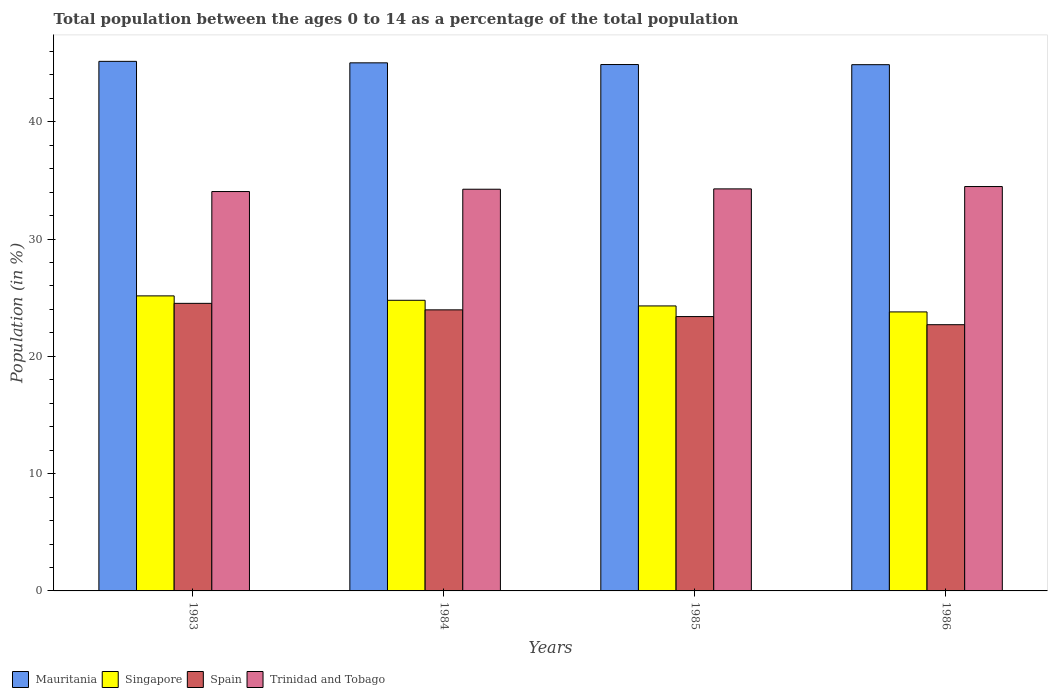How many groups of bars are there?
Your answer should be very brief. 4. Are the number of bars per tick equal to the number of legend labels?
Offer a very short reply. Yes. How many bars are there on the 1st tick from the right?
Your answer should be very brief. 4. What is the label of the 3rd group of bars from the left?
Offer a very short reply. 1985. In how many cases, is the number of bars for a given year not equal to the number of legend labels?
Offer a very short reply. 0. What is the percentage of the population ages 0 to 14 in Trinidad and Tobago in 1985?
Your answer should be very brief. 34.28. Across all years, what is the maximum percentage of the population ages 0 to 14 in Mauritania?
Provide a short and direct response. 45.15. Across all years, what is the minimum percentage of the population ages 0 to 14 in Mauritania?
Provide a short and direct response. 44.87. In which year was the percentage of the population ages 0 to 14 in Trinidad and Tobago maximum?
Give a very brief answer. 1986. What is the total percentage of the population ages 0 to 14 in Spain in the graph?
Provide a short and direct response. 94.57. What is the difference between the percentage of the population ages 0 to 14 in Spain in 1983 and that in 1984?
Ensure brevity in your answer.  0.55. What is the difference between the percentage of the population ages 0 to 14 in Singapore in 1986 and the percentage of the population ages 0 to 14 in Mauritania in 1983?
Offer a very short reply. -21.36. What is the average percentage of the population ages 0 to 14 in Singapore per year?
Your answer should be compact. 24.5. In the year 1983, what is the difference between the percentage of the population ages 0 to 14 in Spain and percentage of the population ages 0 to 14 in Mauritania?
Your answer should be very brief. -20.63. What is the ratio of the percentage of the population ages 0 to 14 in Mauritania in 1985 to that in 1986?
Offer a terse response. 1. What is the difference between the highest and the second highest percentage of the population ages 0 to 14 in Singapore?
Offer a very short reply. 0.38. What is the difference between the highest and the lowest percentage of the population ages 0 to 14 in Spain?
Your answer should be very brief. 1.82. Is it the case that in every year, the sum of the percentage of the population ages 0 to 14 in Singapore and percentage of the population ages 0 to 14 in Mauritania is greater than the sum of percentage of the population ages 0 to 14 in Trinidad and Tobago and percentage of the population ages 0 to 14 in Spain?
Your answer should be compact. No. What does the 2nd bar from the left in 1984 represents?
Ensure brevity in your answer.  Singapore. What does the 3rd bar from the right in 1985 represents?
Provide a succinct answer. Singapore. Is it the case that in every year, the sum of the percentage of the population ages 0 to 14 in Singapore and percentage of the population ages 0 to 14 in Spain is greater than the percentage of the population ages 0 to 14 in Trinidad and Tobago?
Your answer should be compact. Yes. How many bars are there?
Your answer should be compact. 16. What is the difference between two consecutive major ticks on the Y-axis?
Keep it short and to the point. 10. How many legend labels are there?
Give a very brief answer. 4. How are the legend labels stacked?
Provide a succinct answer. Horizontal. What is the title of the graph?
Provide a short and direct response. Total population between the ages 0 to 14 as a percentage of the total population. Does "Hungary" appear as one of the legend labels in the graph?
Offer a terse response. No. What is the label or title of the X-axis?
Provide a short and direct response. Years. What is the Population (in %) of Mauritania in 1983?
Offer a very short reply. 45.15. What is the Population (in %) in Singapore in 1983?
Offer a terse response. 25.15. What is the Population (in %) of Spain in 1983?
Your answer should be very brief. 24.52. What is the Population (in %) in Trinidad and Tobago in 1983?
Give a very brief answer. 34.05. What is the Population (in %) in Mauritania in 1984?
Make the answer very short. 45.02. What is the Population (in %) in Singapore in 1984?
Give a very brief answer. 24.78. What is the Population (in %) of Spain in 1984?
Provide a succinct answer. 23.96. What is the Population (in %) in Trinidad and Tobago in 1984?
Make the answer very short. 34.25. What is the Population (in %) of Mauritania in 1985?
Your answer should be very brief. 44.88. What is the Population (in %) of Singapore in 1985?
Provide a succinct answer. 24.3. What is the Population (in %) in Spain in 1985?
Keep it short and to the point. 23.39. What is the Population (in %) in Trinidad and Tobago in 1985?
Give a very brief answer. 34.28. What is the Population (in %) of Mauritania in 1986?
Provide a short and direct response. 44.87. What is the Population (in %) in Singapore in 1986?
Make the answer very short. 23.79. What is the Population (in %) of Spain in 1986?
Offer a terse response. 22.7. What is the Population (in %) of Trinidad and Tobago in 1986?
Provide a succinct answer. 34.48. Across all years, what is the maximum Population (in %) in Mauritania?
Keep it short and to the point. 45.15. Across all years, what is the maximum Population (in %) of Singapore?
Give a very brief answer. 25.15. Across all years, what is the maximum Population (in %) of Spain?
Your response must be concise. 24.52. Across all years, what is the maximum Population (in %) in Trinidad and Tobago?
Provide a succinct answer. 34.48. Across all years, what is the minimum Population (in %) of Mauritania?
Your answer should be compact. 44.87. Across all years, what is the minimum Population (in %) in Singapore?
Your answer should be very brief. 23.79. Across all years, what is the minimum Population (in %) in Spain?
Offer a terse response. 22.7. Across all years, what is the minimum Population (in %) in Trinidad and Tobago?
Your response must be concise. 34.05. What is the total Population (in %) of Mauritania in the graph?
Your answer should be very brief. 179.91. What is the total Population (in %) in Singapore in the graph?
Provide a short and direct response. 98.02. What is the total Population (in %) in Spain in the graph?
Ensure brevity in your answer.  94.57. What is the total Population (in %) in Trinidad and Tobago in the graph?
Make the answer very short. 137.05. What is the difference between the Population (in %) of Mauritania in 1983 and that in 1984?
Offer a terse response. 0.13. What is the difference between the Population (in %) in Singapore in 1983 and that in 1984?
Your answer should be compact. 0.38. What is the difference between the Population (in %) in Spain in 1983 and that in 1984?
Provide a short and direct response. 0.55. What is the difference between the Population (in %) in Trinidad and Tobago in 1983 and that in 1984?
Keep it short and to the point. -0.2. What is the difference between the Population (in %) in Mauritania in 1983 and that in 1985?
Give a very brief answer. 0.27. What is the difference between the Population (in %) in Singapore in 1983 and that in 1985?
Make the answer very short. 0.86. What is the difference between the Population (in %) of Spain in 1983 and that in 1985?
Offer a very short reply. 1.13. What is the difference between the Population (in %) of Trinidad and Tobago in 1983 and that in 1985?
Offer a terse response. -0.23. What is the difference between the Population (in %) in Mauritania in 1983 and that in 1986?
Give a very brief answer. 0.28. What is the difference between the Population (in %) of Singapore in 1983 and that in 1986?
Provide a succinct answer. 1.37. What is the difference between the Population (in %) of Spain in 1983 and that in 1986?
Offer a terse response. 1.82. What is the difference between the Population (in %) of Trinidad and Tobago in 1983 and that in 1986?
Make the answer very short. -0.43. What is the difference between the Population (in %) in Mauritania in 1984 and that in 1985?
Your answer should be compact. 0.14. What is the difference between the Population (in %) of Singapore in 1984 and that in 1985?
Your answer should be very brief. 0.48. What is the difference between the Population (in %) of Spain in 1984 and that in 1985?
Give a very brief answer. 0.57. What is the difference between the Population (in %) in Trinidad and Tobago in 1984 and that in 1985?
Provide a short and direct response. -0.03. What is the difference between the Population (in %) of Mauritania in 1984 and that in 1986?
Provide a succinct answer. 0.16. What is the difference between the Population (in %) of Spain in 1984 and that in 1986?
Your answer should be compact. 1.26. What is the difference between the Population (in %) of Trinidad and Tobago in 1984 and that in 1986?
Make the answer very short. -0.23. What is the difference between the Population (in %) of Mauritania in 1985 and that in 1986?
Give a very brief answer. 0.01. What is the difference between the Population (in %) of Singapore in 1985 and that in 1986?
Your answer should be very brief. 0.51. What is the difference between the Population (in %) of Spain in 1985 and that in 1986?
Make the answer very short. 0.69. What is the difference between the Population (in %) in Trinidad and Tobago in 1985 and that in 1986?
Ensure brevity in your answer.  -0.2. What is the difference between the Population (in %) of Mauritania in 1983 and the Population (in %) of Singapore in 1984?
Keep it short and to the point. 20.37. What is the difference between the Population (in %) in Mauritania in 1983 and the Population (in %) in Spain in 1984?
Your answer should be compact. 21.19. What is the difference between the Population (in %) of Mauritania in 1983 and the Population (in %) of Trinidad and Tobago in 1984?
Your response must be concise. 10.9. What is the difference between the Population (in %) of Singapore in 1983 and the Population (in %) of Spain in 1984?
Offer a terse response. 1.19. What is the difference between the Population (in %) in Singapore in 1983 and the Population (in %) in Trinidad and Tobago in 1984?
Your response must be concise. -9.09. What is the difference between the Population (in %) of Spain in 1983 and the Population (in %) of Trinidad and Tobago in 1984?
Your response must be concise. -9.73. What is the difference between the Population (in %) in Mauritania in 1983 and the Population (in %) in Singapore in 1985?
Make the answer very short. 20.85. What is the difference between the Population (in %) of Mauritania in 1983 and the Population (in %) of Spain in 1985?
Keep it short and to the point. 21.76. What is the difference between the Population (in %) in Mauritania in 1983 and the Population (in %) in Trinidad and Tobago in 1985?
Your response must be concise. 10.87. What is the difference between the Population (in %) of Singapore in 1983 and the Population (in %) of Spain in 1985?
Ensure brevity in your answer.  1.76. What is the difference between the Population (in %) in Singapore in 1983 and the Population (in %) in Trinidad and Tobago in 1985?
Ensure brevity in your answer.  -9.12. What is the difference between the Population (in %) of Spain in 1983 and the Population (in %) of Trinidad and Tobago in 1985?
Give a very brief answer. -9.76. What is the difference between the Population (in %) of Mauritania in 1983 and the Population (in %) of Singapore in 1986?
Offer a terse response. 21.36. What is the difference between the Population (in %) in Mauritania in 1983 and the Population (in %) in Spain in 1986?
Offer a very short reply. 22.45. What is the difference between the Population (in %) of Mauritania in 1983 and the Population (in %) of Trinidad and Tobago in 1986?
Provide a succinct answer. 10.67. What is the difference between the Population (in %) in Singapore in 1983 and the Population (in %) in Spain in 1986?
Your response must be concise. 2.46. What is the difference between the Population (in %) in Singapore in 1983 and the Population (in %) in Trinidad and Tobago in 1986?
Your answer should be compact. -9.32. What is the difference between the Population (in %) in Spain in 1983 and the Population (in %) in Trinidad and Tobago in 1986?
Give a very brief answer. -9.96. What is the difference between the Population (in %) of Mauritania in 1984 and the Population (in %) of Singapore in 1985?
Your response must be concise. 20.73. What is the difference between the Population (in %) in Mauritania in 1984 and the Population (in %) in Spain in 1985?
Your response must be concise. 21.63. What is the difference between the Population (in %) of Mauritania in 1984 and the Population (in %) of Trinidad and Tobago in 1985?
Offer a very short reply. 10.75. What is the difference between the Population (in %) in Singapore in 1984 and the Population (in %) in Spain in 1985?
Offer a terse response. 1.39. What is the difference between the Population (in %) of Singapore in 1984 and the Population (in %) of Trinidad and Tobago in 1985?
Provide a short and direct response. -9.5. What is the difference between the Population (in %) in Spain in 1984 and the Population (in %) in Trinidad and Tobago in 1985?
Ensure brevity in your answer.  -10.31. What is the difference between the Population (in %) in Mauritania in 1984 and the Population (in %) in Singapore in 1986?
Your answer should be very brief. 21.24. What is the difference between the Population (in %) of Mauritania in 1984 and the Population (in %) of Spain in 1986?
Your response must be concise. 22.32. What is the difference between the Population (in %) of Mauritania in 1984 and the Population (in %) of Trinidad and Tobago in 1986?
Give a very brief answer. 10.55. What is the difference between the Population (in %) of Singapore in 1984 and the Population (in %) of Spain in 1986?
Ensure brevity in your answer.  2.08. What is the difference between the Population (in %) of Singapore in 1984 and the Population (in %) of Trinidad and Tobago in 1986?
Make the answer very short. -9.7. What is the difference between the Population (in %) of Spain in 1984 and the Population (in %) of Trinidad and Tobago in 1986?
Offer a terse response. -10.51. What is the difference between the Population (in %) in Mauritania in 1985 and the Population (in %) in Singapore in 1986?
Give a very brief answer. 21.09. What is the difference between the Population (in %) of Mauritania in 1985 and the Population (in %) of Spain in 1986?
Your answer should be compact. 22.18. What is the difference between the Population (in %) in Mauritania in 1985 and the Population (in %) in Trinidad and Tobago in 1986?
Give a very brief answer. 10.4. What is the difference between the Population (in %) in Singapore in 1985 and the Population (in %) in Spain in 1986?
Provide a short and direct response. 1.6. What is the difference between the Population (in %) of Singapore in 1985 and the Population (in %) of Trinidad and Tobago in 1986?
Make the answer very short. -10.18. What is the difference between the Population (in %) in Spain in 1985 and the Population (in %) in Trinidad and Tobago in 1986?
Your response must be concise. -11.08. What is the average Population (in %) in Mauritania per year?
Your answer should be very brief. 44.98. What is the average Population (in %) of Singapore per year?
Make the answer very short. 24.5. What is the average Population (in %) of Spain per year?
Give a very brief answer. 23.64. What is the average Population (in %) in Trinidad and Tobago per year?
Provide a short and direct response. 34.26. In the year 1983, what is the difference between the Population (in %) in Mauritania and Population (in %) in Singapore?
Offer a very short reply. 19.99. In the year 1983, what is the difference between the Population (in %) in Mauritania and Population (in %) in Spain?
Your answer should be very brief. 20.63. In the year 1983, what is the difference between the Population (in %) in Mauritania and Population (in %) in Trinidad and Tobago?
Keep it short and to the point. 11.1. In the year 1983, what is the difference between the Population (in %) in Singapore and Population (in %) in Spain?
Provide a short and direct response. 0.64. In the year 1983, what is the difference between the Population (in %) of Singapore and Population (in %) of Trinidad and Tobago?
Provide a succinct answer. -8.9. In the year 1983, what is the difference between the Population (in %) of Spain and Population (in %) of Trinidad and Tobago?
Provide a short and direct response. -9.53. In the year 1984, what is the difference between the Population (in %) in Mauritania and Population (in %) in Singapore?
Keep it short and to the point. 20.24. In the year 1984, what is the difference between the Population (in %) in Mauritania and Population (in %) in Spain?
Provide a succinct answer. 21.06. In the year 1984, what is the difference between the Population (in %) of Mauritania and Population (in %) of Trinidad and Tobago?
Keep it short and to the point. 10.78. In the year 1984, what is the difference between the Population (in %) in Singapore and Population (in %) in Spain?
Provide a short and direct response. 0.82. In the year 1984, what is the difference between the Population (in %) of Singapore and Population (in %) of Trinidad and Tobago?
Your answer should be very brief. -9.47. In the year 1984, what is the difference between the Population (in %) of Spain and Population (in %) of Trinidad and Tobago?
Provide a succinct answer. -10.28. In the year 1985, what is the difference between the Population (in %) in Mauritania and Population (in %) in Singapore?
Offer a terse response. 20.58. In the year 1985, what is the difference between the Population (in %) of Mauritania and Population (in %) of Spain?
Your answer should be compact. 21.49. In the year 1985, what is the difference between the Population (in %) in Mauritania and Population (in %) in Trinidad and Tobago?
Keep it short and to the point. 10.6. In the year 1985, what is the difference between the Population (in %) in Singapore and Population (in %) in Spain?
Ensure brevity in your answer.  0.91. In the year 1985, what is the difference between the Population (in %) of Singapore and Population (in %) of Trinidad and Tobago?
Keep it short and to the point. -9.98. In the year 1985, what is the difference between the Population (in %) of Spain and Population (in %) of Trinidad and Tobago?
Keep it short and to the point. -10.89. In the year 1986, what is the difference between the Population (in %) in Mauritania and Population (in %) in Singapore?
Give a very brief answer. 21.08. In the year 1986, what is the difference between the Population (in %) in Mauritania and Population (in %) in Spain?
Keep it short and to the point. 22.17. In the year 1986, what is the difference between the Population (in %) of Mauritania and Population (in %) of Trinidad and Tobago?
Give a very brief answer. 10.39. In the year 1986, what is the difference between the Population (in %) of Singapore and Population (in %) of Spain?
Offer a very short reply. 1.09. In the year 1986, what is the difference between the Population (in %) in Singapore and Population (in %) in Trinidad and Tobago?
Offer a terse response. -10.69. In the year 1986, what is the difference between the Population (in %) in Spain and Population (in %) in Trinidad and Tobago?
Offer a terse response. -11.78. What is the ratio of the Population (in %) in Singapore in 1983 to that in 1984?
Offer a terse response. 1.02. What is the ratio of the Population (in %) in Spain in 1983 to that in 1984?
Ensure brevity in your answer.  1.02. What is the ratio of the Population (in %) in Trinidad and Tobago in 1983 to that in 1984?
Your answer should be compact. 0.99. What is the ratio of the Population (in %) of Mauritania in 1983 to that in 1985?
Make the answer very short. 1.01. What is the ratio of the Population (in %) of Singapore in 1983 to that in 1985?
Give a very brief answer. 1.04. What is the ratio of the Population (in %) of Spain in 1983 to that in 1985?
Give a very brief answer. 1.05. What is the ratio of the Population (in %) in Singapore in 1983 to that in 1986?
Offer a very short reply. 1.06. What is the ratio of the Population (in %) in Spain in 1983 to that in 1986?
Your response must be concise. 1.08. What is the ratio of the Population (in %) of Trinidad and Tobago in 1983 to that in 1986?
Your answer should be compact. 0.99. What is the ratio of the Population (in %) in Singapore in 1984 to that in 1985?
Offer a terse response. 1.02. What is the ratio of the Population (in %) of Spain in 1984 to that in 1985?
Your answer should be very brief. 1.02. What is the ratio of the Population (in %) of Trinidad and Tobago in 1984 to that in 1985?
Give a very brief answer. 1. What is the ratio of the Population (in %) in Singapore in 1984 to that in 1986?
Your answer should be compact. 1.04. What is the ratio of the Population (in %) of Spain in 1984 to that in 1986?
Provide a succinct answer. 1.06. What is the ratio of the Population (in %) in Trinidad and Tobago in 1984 to that in 1986?
Give a very brief answer. 0.99. What is the ratio of the Population (in %) in Mauritania in 1985 to that in 1986?
Offer a terse response. 1. What is the ratio of the Population (in %) of Singapore in 1985 to that in 1986?
Keep it short and to the point. 1.02. What is the ratio of the Population (in %) in Spain in 1985 to that in 1986?
Give a very brief answer. 1.03. What is the ratio of the Population (in %) of Trinidad and Tobago in 1985 to that in 1986?
Ensure brevity in your answer.  0.99. What is the difference between the highest and the second highest Population (in %) of Mauritania?
Provide a succinct answer. 0.13. What is the difference between the highest and the second highest Population (in %) of Singapore?
Ensure brevity in your answer.  0.38. What is the difference between the highest and the second highest Population (in %) of Spain?
Ensure brevity in your answer.  0.55. What is the difference between the highest and the second highest Population (in %) in Trinidad and Tobago?
Give a very brief answer. 0.2. What is the difference between the highest and the lowest Population (in %) of Mauritania?
Your answer should be very brief. 0.28. What is the difference between the highest and the lowest Population (in %) of Singapore?
Offer a terse response. 1.37. What is the difference between the highest and the lowest Population (in %) in Spain?
Keep it short and to the point. 1.82. What is the difference between the highest and the lowest Population (in %) of Trinidad and Tobago?
Keep it short and to the point. 0.43. 